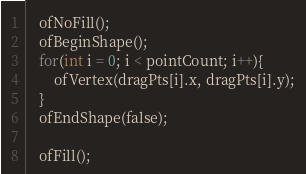Convert code to text. <code><loc_0><loc_0><loc_500><loc_500><_ObjectiveC_>	ofNoFill();
	ofBeginShape();
	for(int i = 0; i < pointCount; i++){
		ofVertex(dragPts[i].x, dragPts[i].y);
	}
	ofEndShape(false);

    ofFill();
</code> 